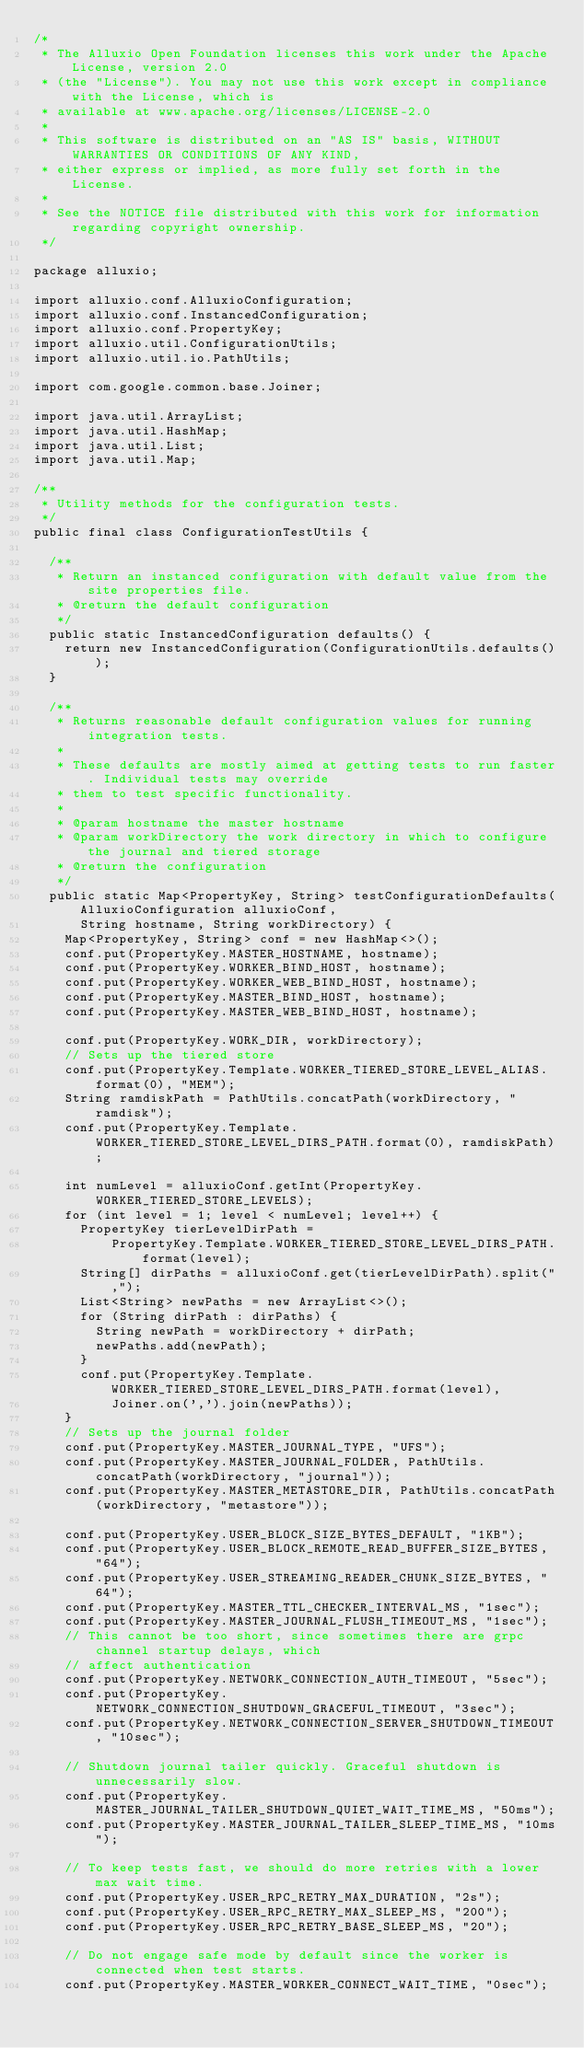<code> <loc_0><loc_0><loc_500><loc_500><_Java_>/*
 * The Alluxio Open Foundation licenses this work under the Apache License, version 2.0
 * (the "License"). You may not use this work except in compliance with the License, which is
 * available at www.apache.org/licenses/LICENSE-2.0
 *
 * This software is distributed on an "AS IS" basis, WITHOUT WARRANTIES OR CONDITIONS OF ANY KIND,
 * either express or implied, as more fully set forth in the License.
 *
 * See the NOTICE file distributed with this work for information regarding copyright ownership.
 */

package alluxio;

import alluxio.conf.AlluxioConfiguration;
import alluxio.conf.InstancedConfiguration;
import alluxio.conf.PropertyKey;
import alluxio.util.ConfigurationUtils;
import alluxio.util.io.PathUtils;

import com.google.common.base.Joiner;

import java.util.ArrayList;
import java.util.HashMap;
import java.util.List;
import java.util.Map;

/**
 * Utility methods for the configuration tests.
 */
public final class ConfigurationTestUtils {

  /**
   * Return an instanced configuration with default value from the site properties file.
   * @return the default configuration
   */
  public static InstancedConfiguration defaults() {
    return new InstancedConfiguration(ConfigurationUtils.defaults());
  }

  /**
   * Returns reasonable default configuration values for running integration tests.
   *
   * These defaults are mostly aimed at getting tests to run faster. Individual tests may override
   * them to test specific functionality.
   *
   * @param hostname the master hostname
   * @param workDirectory the work directory in which to configure the journal and tiered storage
   * @return the configuration
   */
  public static Map<PropertyKey, String> testConfigurationDefaults(AlluxioConfiguration alluxioConf,
      String hostname, String workDirectory) {
    Map<PropertyKey, String> conf = new HashMap<>();
    conf.put(PropertyKey.MASTER_HOSTNAME, hostname);
    conf.put(PropertyKey.WORKER_BIND_HOST, hostname);
    conf.put(PropertyKey.WORKER_WEB_BIND_HOST, hostname);
    conf.put(PropertyKey.MASTER_BIND_HOST, hostname);
    conf.put(PropertyKey.MASTER_WEB_BIND_HOST, hostname);

    conf.put(PropertyKey.WORK_DIR, workDirectory);
    // Sets up the tiered store
    conf.put(PropertyKey.Template.WORKER_TIERED_STORE_LEVEL_ALIAS.format(0), "MEM");
    String ramdiskPath = PathUtils.concatPath(workDirectory, "ramdisk");
    conf.put(PropertyKey.Template.WORKER_TIERED_STORE_LEVEL_DIRS_PATH.format(0), ramdiskPath);

    int numLevel = alluxioConf.getInt(PropertyKey.WORKER_TIERED_STORE_LEVELS);
    for (int level = 1; level < numLevel; level++) {
      PropertyKey tierLevelDirPath =
          PropertyKey.Template.WORKER_TIERED_STORE_LEVEL_DIRS_PATH.format(level);
      String[] dirPaths = alluxioConf.get(tierLevelDirPath).split(",");
      List<String> newPaths = new ArrayList<>();
      for (String dirPath : dirPaths) {
        String newPath = workDirectory + dirPath;
        newPaths.add(newPath);
      }
      conf.put(PropertyKey.Template.WORKER_TIERED_STORE_LEVEL_DIRS_PATH.format(level),
          Joiner.on(',').join(newPaths));
    }
    // Sets up the journal folder
    conf.put(PropertyKey.MASTER_JOURNAL_TYPE, "UFS");
    conf.put(PropertyKey.MASTER_JOURNAL_FOLDER, PathUtils.concatPath(workDirectory, "journal"));
    conf.put(PropertyKey.MASTER_METASTORE_DIR, PathUtils.concatPath(workDirectory, "metastore"));

    conf.put(PropertyKey.USER_BLOCK_SIZE_BYTES_DEFAULT, "1KB");
    conf.put(PropertyKey.USER_BLOCK_REMOTE_READ_BUFFER_SIZE_BYTES, "64");
    conf.put(PropertyKey.USER_STREAMING_READER_CHUNK_SIZE_BYTES, "64");
    conf.put(PropertyKey.MASTER_TTL_CHECKER_INTERVAL_MS, "1sec");
    conf.put(PropertyKey.MASTER_JOURNAL_FLUSH_TIMEOUT_MS, "1sec");
    // This cannot be too short, since sometimes there are grpc channel startup delays, which
    // affect authentication
    conf.put(PropertyKey.NETWORK_CONNECTION_AUTH_TIMEOUT, "5sec");
    conf.put(PropertyKey.NETWORK_CONNECTION_SHUTDOWN_GRACEFUL_TIMEOUT, "3sec");
    conf.put(PropertyKey.NETWORK_CONNECTION_SERVER_SHUTDOWN_TIMEOUT, "10sec");

    // Shutdown journal tailer quickly. Graceful shutdown is unnecessarily slow.
    conf.put(PropertyKey.MASTER_JOURNAL_TAILER_SHUTDOWN_QUIET_WAIT_TIME_MS, "50ms");
    conf.put(PropertyKey.MASTER_JOURNAL_TAILER_SLEEP_TIME_MS, "10ms");

    // To keep tests fast, we should do more retries with a lower max wait time.
    conf.put(PropertyKey.USER_RPC_RETRY_MAX_DURATION, "2s");
    conf.put(PropertyKey.USER_RPC_RETRY_MAX_SLEEP_MS, "200");
    conf.put(PropertyKey.USER_RPC_RETRY_BASE_SLEEP_MS, "20");

    // Do not engage safe mode by default since the worker is connected when test starts.
    conf.put(PropertyKey.MASTER_WORKER_CONNECT_WAIT_TIME, "0sec");
</code> 